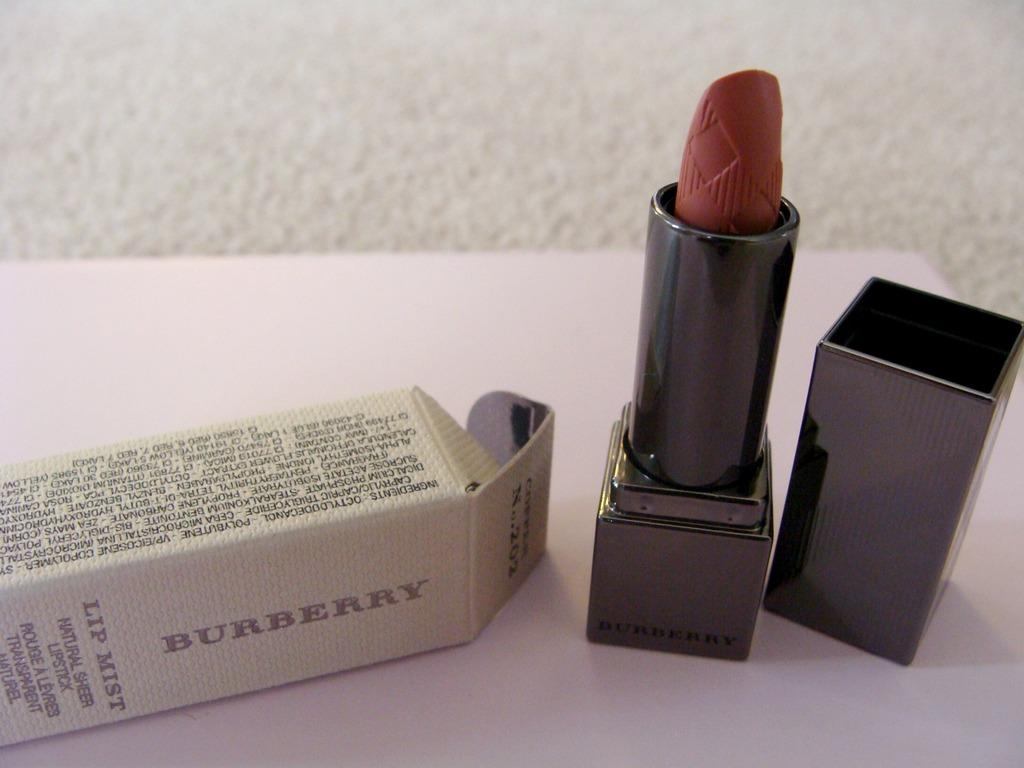<image>
Provide a brief description of the given image. burberrylip mist lipstick box on its side and the lipstick with the lid off 